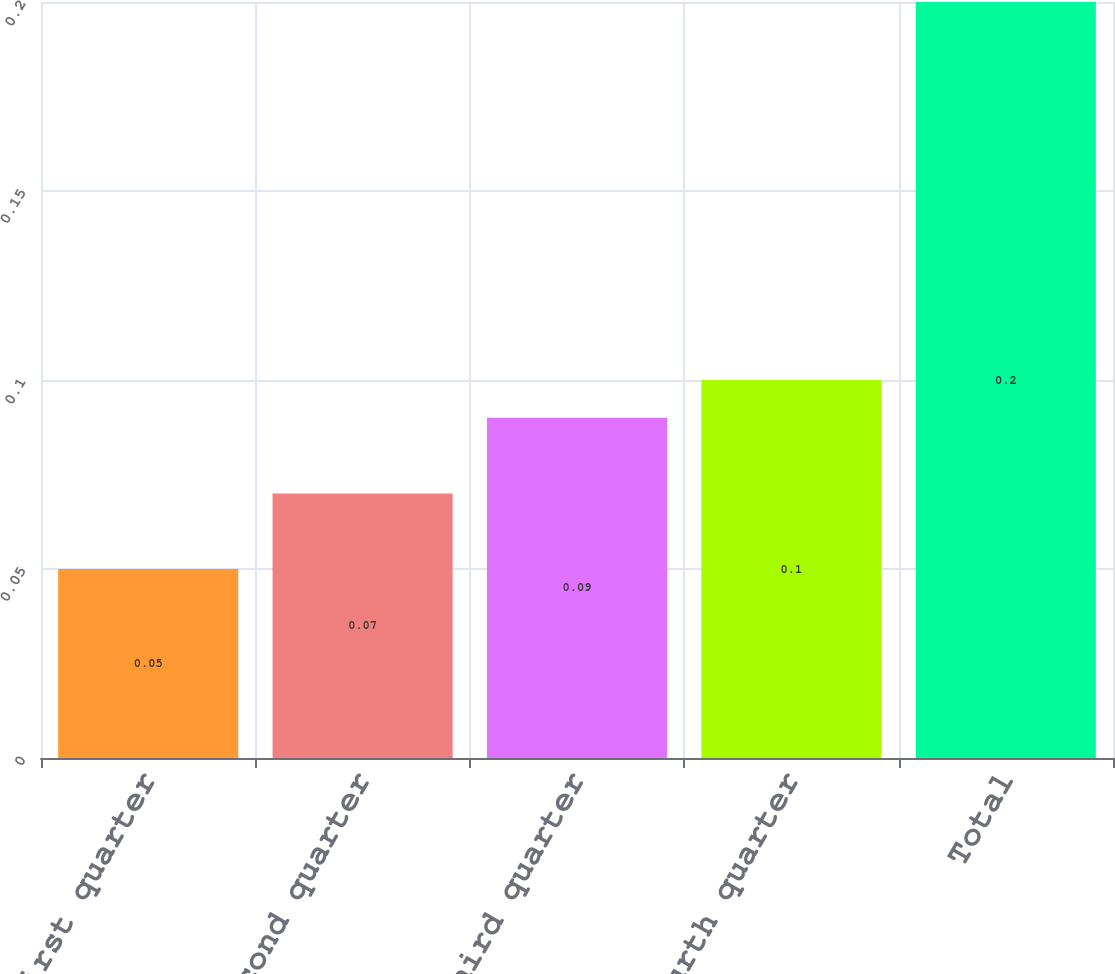Convert chart. <chart><loc_0><loc_0><loc_500><loc_500><bar_chart><fcel>First quarter<fcel>Second quarter<fcel>Third quarter<fcel>Fourth quarter<fcel>Total<nl><fcel>0.05<fcel>0.07<fcel>0.09<fcel>0.1<fcel>0.2<nl></chart> 